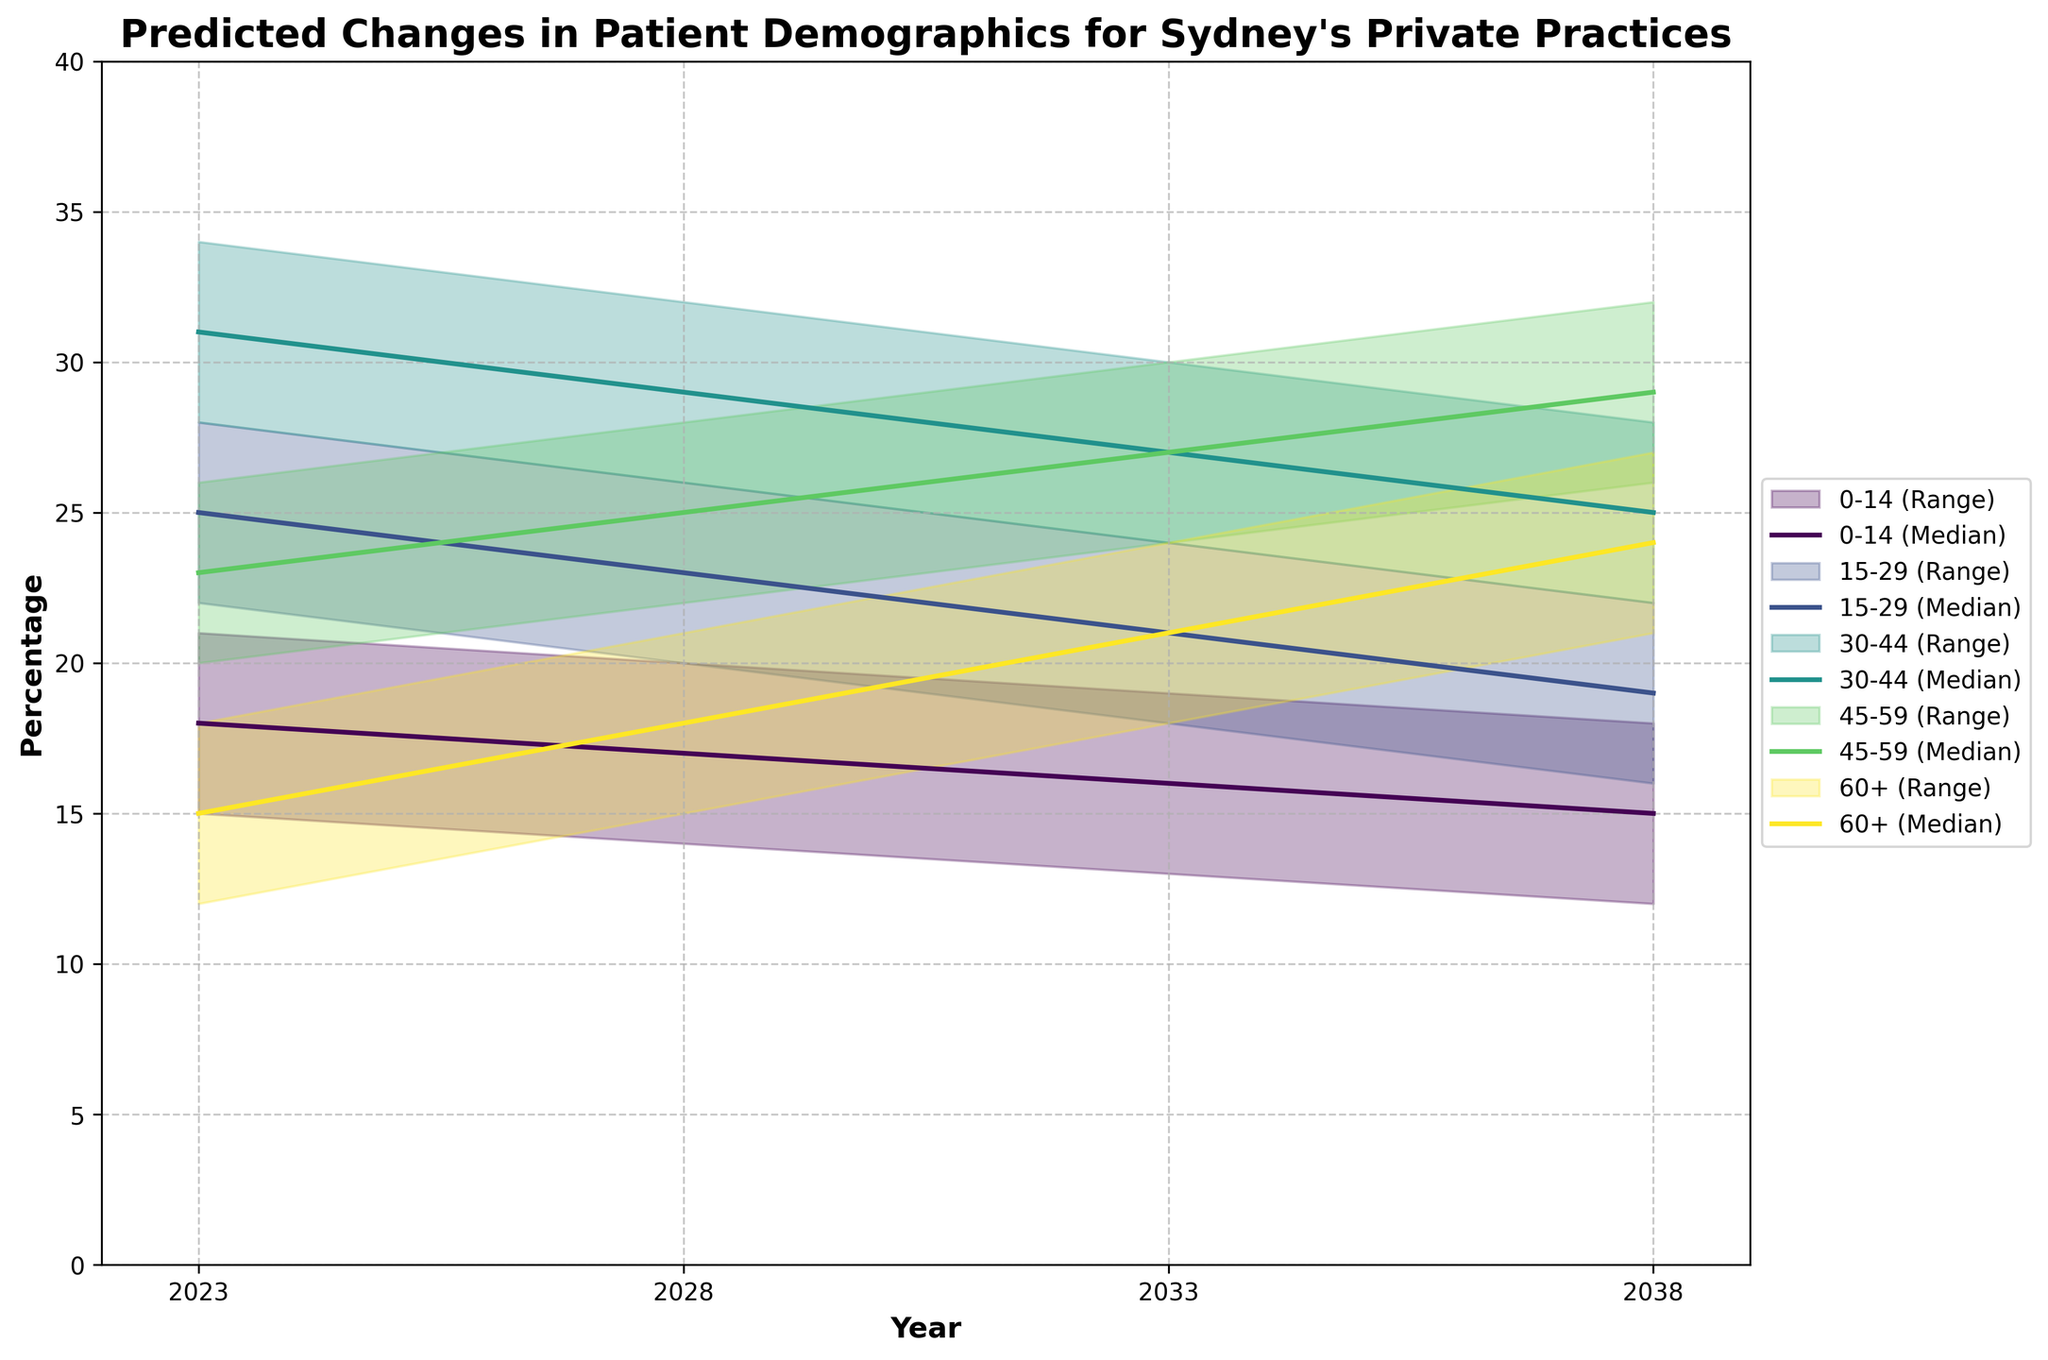What's the title of the chart? The title of the chart is displayed at the top and is usually a summarization of the key insights.
Answer: Predicted Changes in Patient Demographics for Sydney's Private Practices What age group is predicted to have the highest median percentage in 2028? Look at the median lines for each age group in 2028 and identify which one is the highest. The 30-44 age group has the highest median value.
Answer: 30-44 What is the predicted range for the 60+ age group in 2038? Observe the upper and lower bounds for the 60+ age group in 2038. The range is between the lowest and highest values within that year.
Answer: 21-27 Which age group shows an increasing trend in median percentage over the 15 years shown? Check the trend lines for the medians of each age group from 2023 to 2038. Identify the group whose median values are increasing.
Answer: 60+ By how much is the median percentage of the 0-14 age group expected to decrease from 2023 to 2038? Calculate the difference between the median percentage of the 0-14 age group in 2023 and in 2038. The median in 2023 is 18, and in 2038 it is 15. The decrease is 18 - 15.
Answer: 3 Which age group has the widest predicted range in any given year, and what is that range? Look for the age group with the largest difference between the upper and lower bounds in any year. The 45-59 age group in 2038 has the widest range (26-32).
Answer: 45-59, 6 Are there any age groups that are predicted to have a decreasing trend in their lower bound values from 2023 to 2038? Check the lower bound values for each age group across the years. Identify if any of them are decreasing. The 0-14 age group has a decreasing lower bound from 15 in 2023 to 12 in 2038.
Answer: Yes, 0-14 What is the expected median percentage for the 15-29 age group in 2033? Look at the median percentage for the 15-29 age group specifically in the year 2033.
Answer: 21 How does the upper bound for the 45-59 age group in 2023 compare to its median in 2038? Compare the upper bound value for 2023 with the median value for 2038 for the 45-59 age group. The upper bound in 2023 is 26, and the median in 2038 is 29.
Answer: The 2038 median is higher by 3 than the 2023 upper bound 